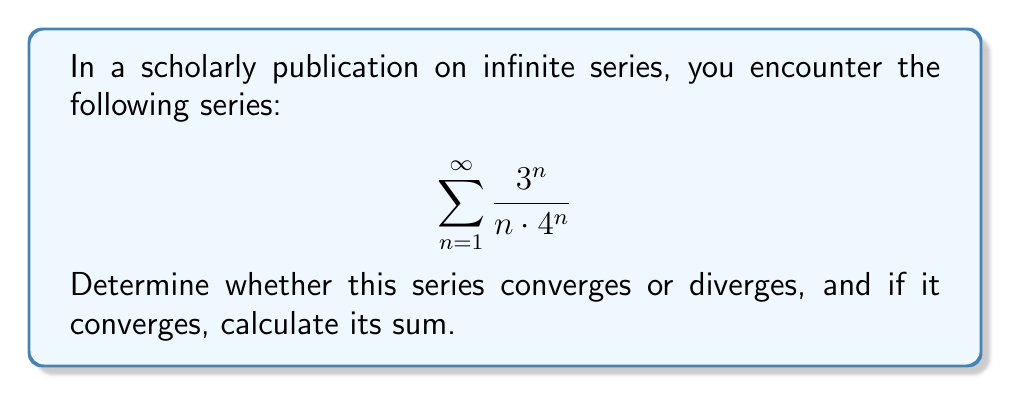Teach me how to tackle this problem. To determine the convergence and sum of this series, we'll follow these steps:

1) First, let's use the ratio test to check for convergence:

   Let $a_n = \frac{3^n}{n \cdot 4^n}$
   
   $$\lim_{n \to \infty} \left|\frac{a_{n+1}}{a_n}\right| = \lim_{n \to \infty} \left|\frac{\frac{3^{n+1}}{(n+1) \cdot 4^{n+1}}}{\frac{3^n}{n \cdot 4^n}}\right|$$

   $$= \lim_{n \to \infty} \left|\frac{3^{n+1}}{(n+1) \cdot 4^{n+1}} \cdot \frac{n \cdot 4^n}{3^n}\right|$$

   $$= \lim_{n \to \infty} \left|\frac{3 \cdot n}{(n+1) \cdot 4}\right| = \lim_{n \to \infty} \frac{3n}{4n+4} = \frac{3}{4} < 1$$

   Since the limit is less than 1, the series converges.

2) Now that we know it converges, let's find its sum. We can rewrite the series as:

   $$\sum_{n=1}^{\infty} \frac{1}{n} \cdot \left(\frac{3}{4}\right)^n$$

3) This is of the form $\sum_{n=1}^{\infty} \frac{x^n}{n}$, which is the Maclaurin series for $-\ln(1-x)$, where $|x| < 1$.

4) In our case, $x = \frac{3}{4}$, which satisfies $|x| < 1$.

5) Therefore, the sum of our series is:

   $$-\ln\left(1-\frac{3}{4}\right) = -\ln\left(\frac{1}{4}\right) = \ln(4)$$

Thus, the series converges to $\ln(4)$.
Answer: The series converges; sum = $\ln(4)$ 